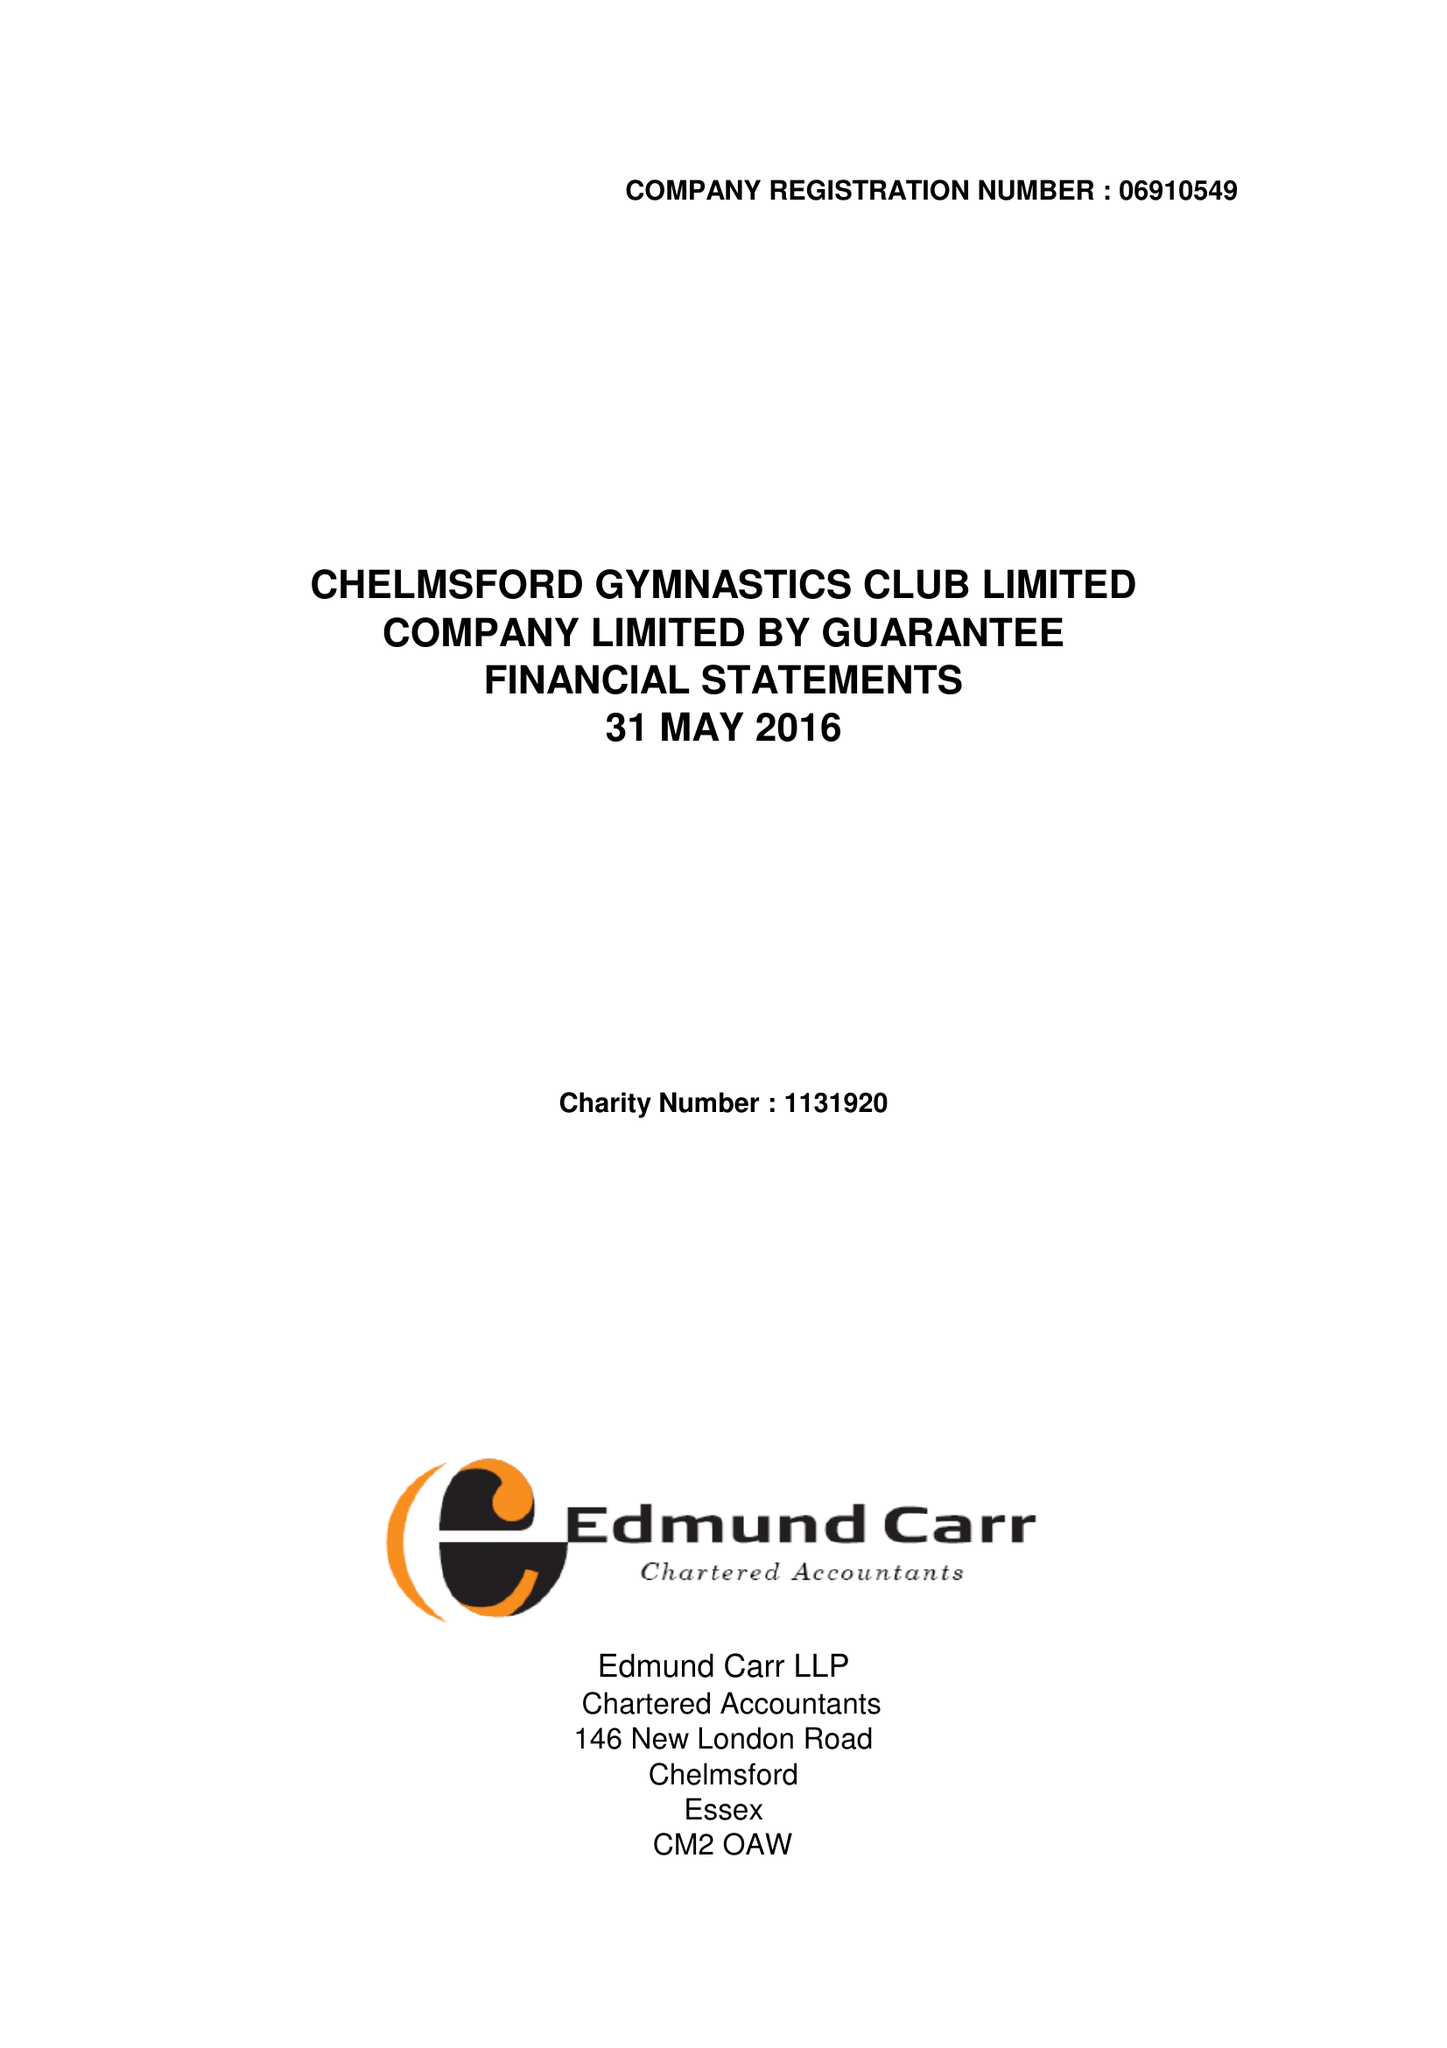What is the value for the spending_annually_in_british_pounds?
Answer the question using a single word or phrase. 389294.00 